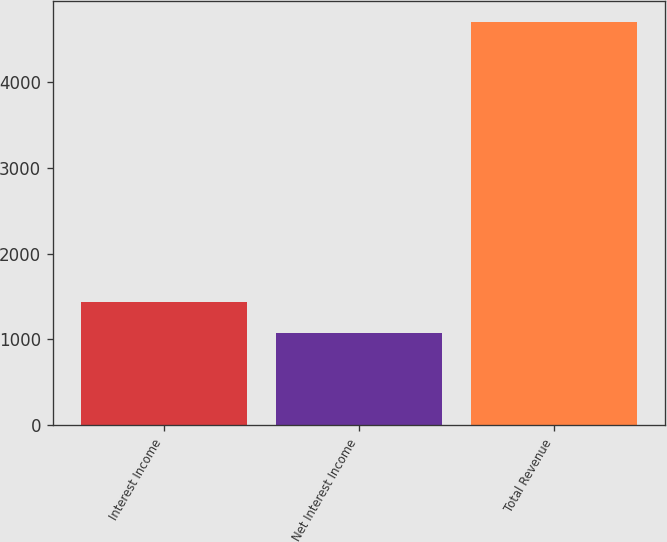<chart> <loc_0><loc_0><loc_500><loc_500><bar_chart><fcel>Interest Income<fcel>Net Interest Income<fcel>Total Revenue<nl><fcel>1433.35<fcel>1070.1<fcel>4702.6<nl></chart> 